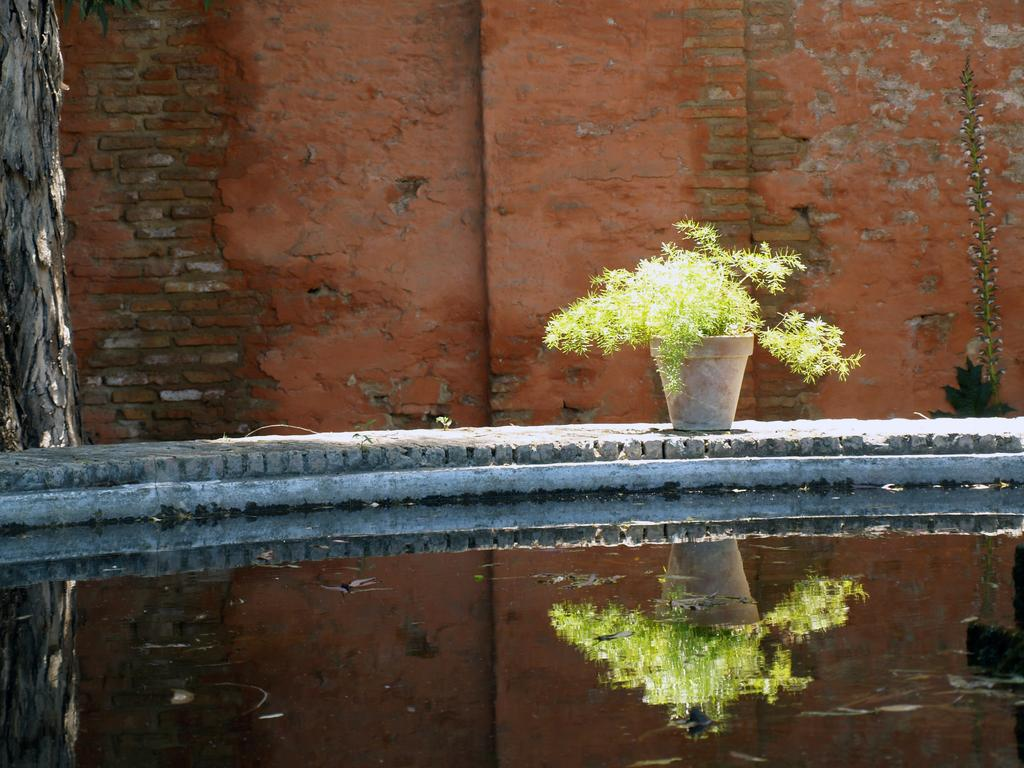What type of plant is visible in the image? There is a house plant in the image. What else is present in the image besides the house plant? There is water in the image, and the water reflects the house plant. What can be seen in the background of the image? There is a wall in the background of the image. What is the price of the island visible in the image? There is no island present in the image; it features a house plant and water reflecting the plant. How many flights are shown taking off from the wall in the background? There are no flights visible in the image, as it only shows a house plant, water, and a wall in the background. 